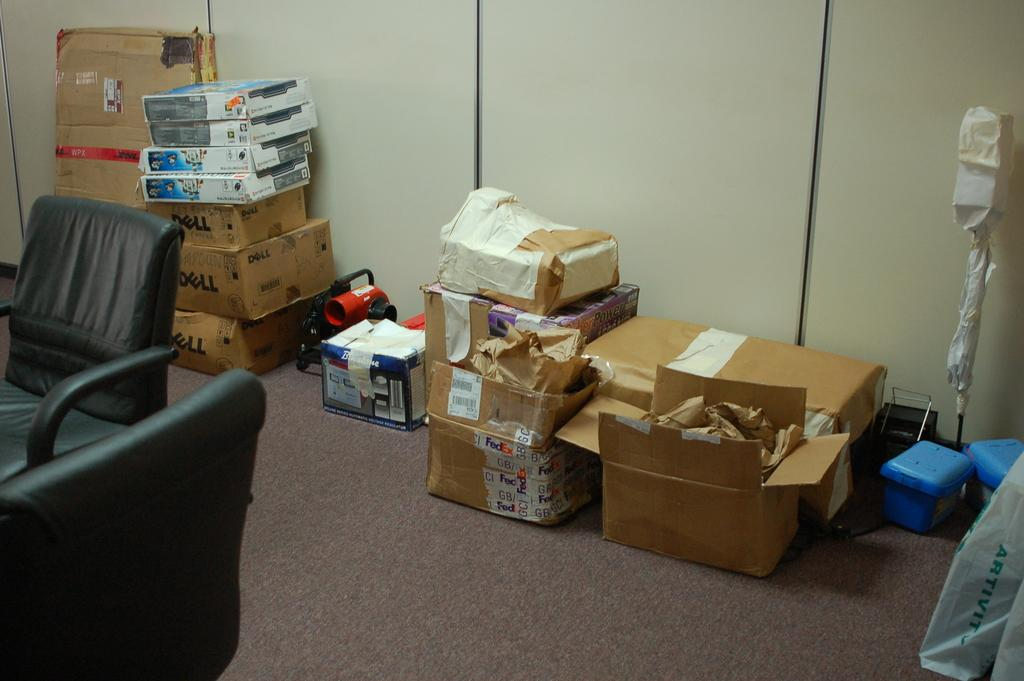What type of furniture is present in the image? There is a chair in the image. What other objects can be seen in the image besides the chair? There are two or more boxes in the image. What type of straw is used to create the account in the image? There is no straw or account present in the image. 